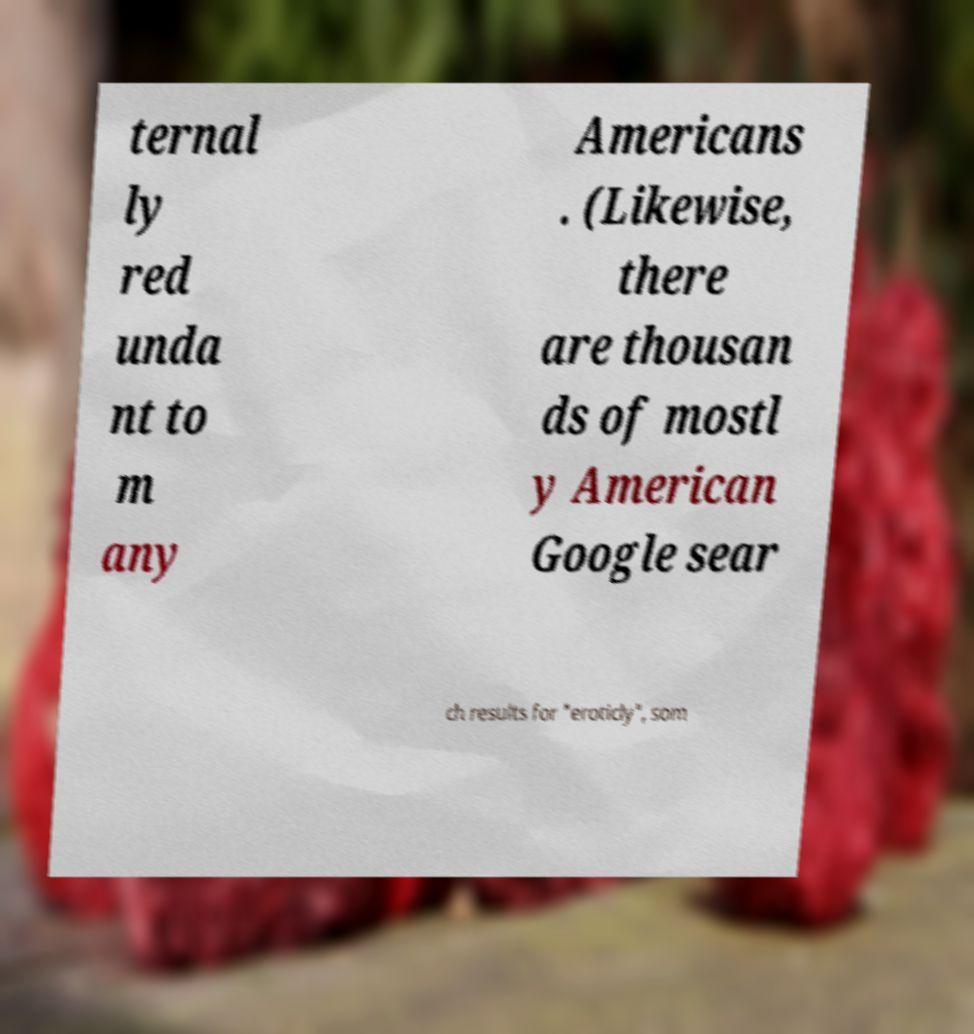I need the written content from this picture converted into text. Can you do that? ternal ly red unda nt to m any Americans . (Likewise, there are thousan ds of mostl y American Google sear ch results for "eroticly", som 